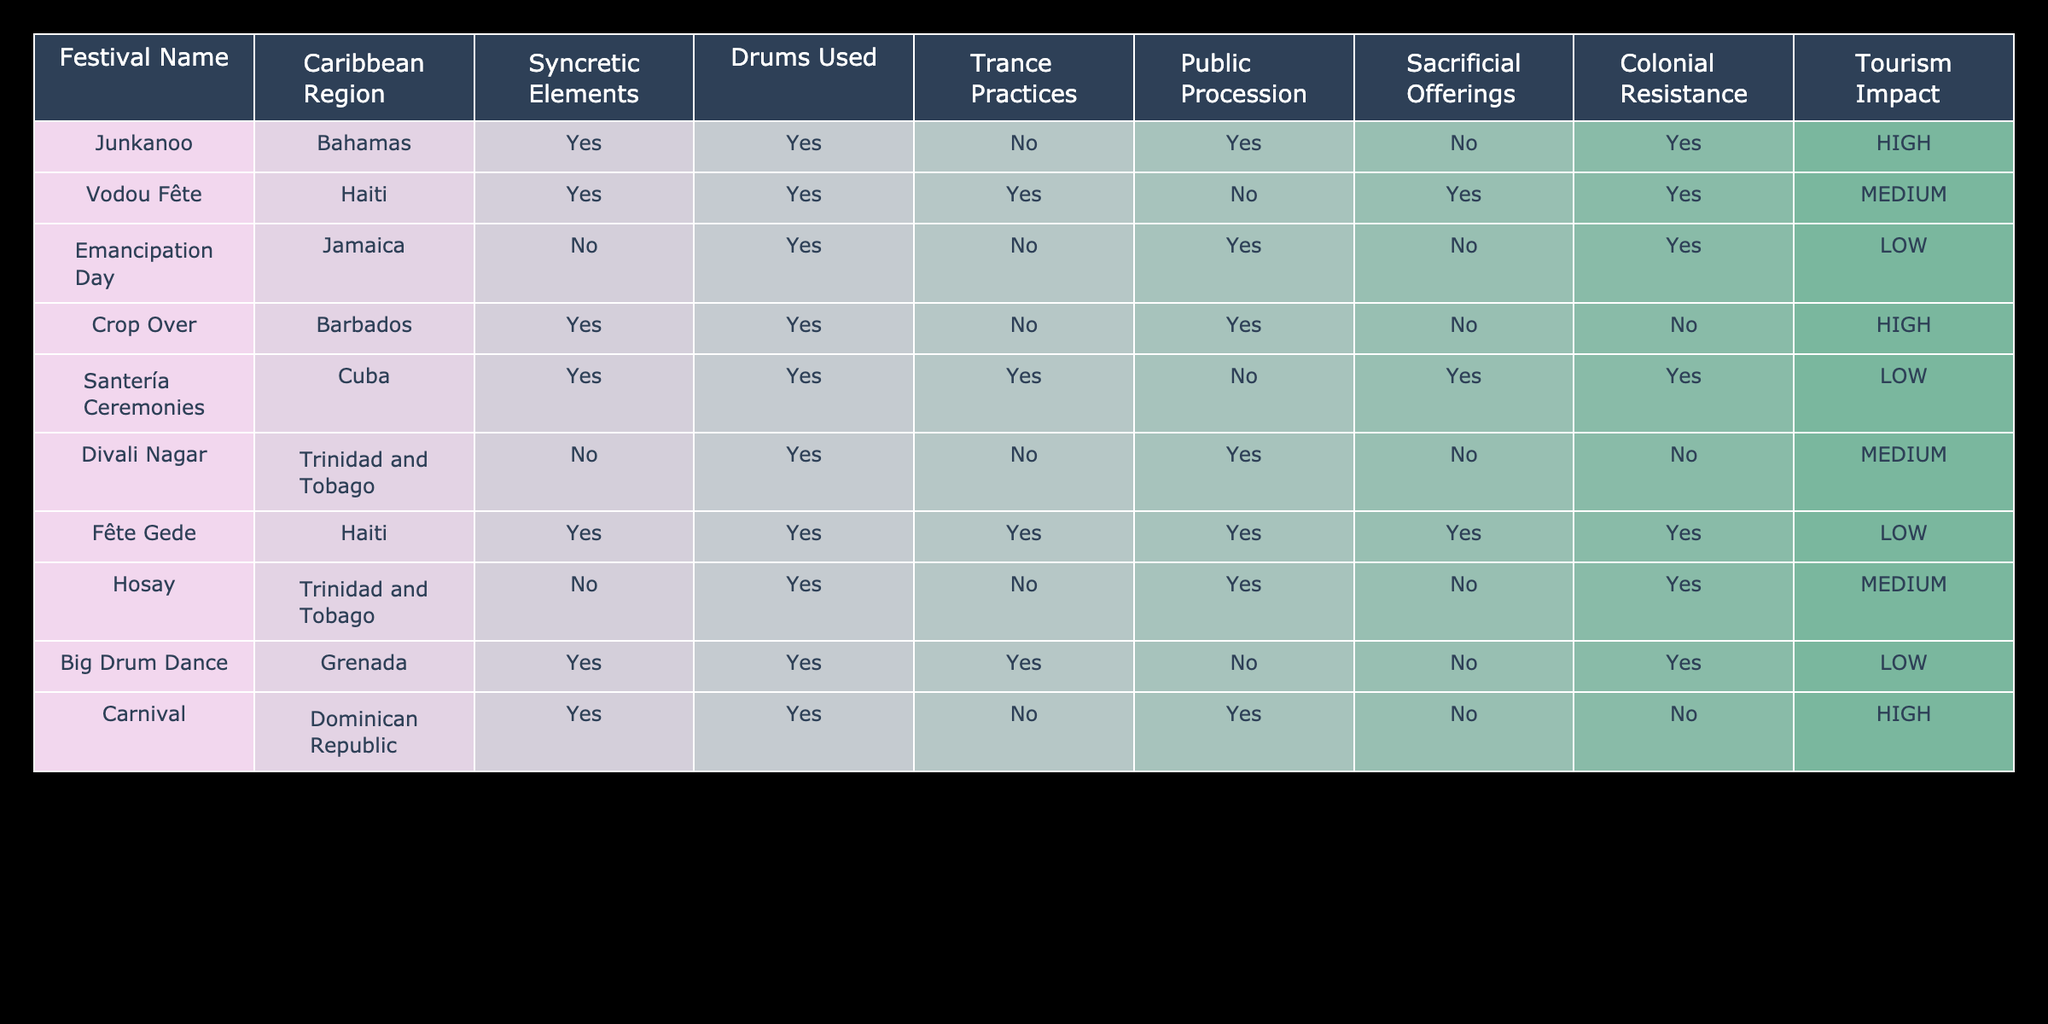What percentage of festivals include syncretic elements? There are 10 festivals in total, and 6 of them (Junkanoo, Vodou Fête, Crop Over, Santería Ceremonies, Fête Gede, Carnival) include syncretic elements. To calculate the percentage, divide 6 by 10 and multiply by 100, resulting in 60%.
Answer: 60% Which festival has the highest tourism impact? By examining the tourism impact column, we can see that both Junkanoo and Carnival are marked as high.
Answer: Junkanoo and Carnival Is there a festival that features sacrificial offerings and trance practices? Looking through the table, Fête Gede has both sacrificial offerings and trance practices marked as yes.
Answer: Yes How many festivals have public processions but do not have trance practices? By checking the table, we find that Emancipation Day, Divali Nagar, and Hosay have public processions and do not include trance practices. Thus, that's 3 festivals.
Answer: 3 What is the difference in the number of festivals with drums used versus those without drums used? From the table, all except for Emancipation Day, Divali Nagar, and Big Drum Dance use drums. Therefore, 7 festivals use drums, and 3 do not. The difference is 7 - 3 = 4.
Answer: 4 Which festival has the lowest tourism impact and features colonial resistance? Referring to the tourism impact column, we see that both Santería Ceremonies and Big Drum Dance have a low impact. However, only Santería Ceremonies appears with colonial resistance marked as yes.
Answer: Santería Ceremonies Are there any festivals that both have syncretic elements and are considered a form of colonial resistance? Looking at the table, Junkanoo, Vodou Fête, and Fête Gede have syncretic elements and colonial resistance marked as yes.
Answer: Yes How many festivals are celebrated in Trinidad and Tobago, and what is their average tourism impact? There are 2 festivals in Trinidad and Tobago (Divali Nagar and Hosay). Their tourism impacts are medium and medium, which can be assigned a value of 2 (medium). The average, therefore, is 2/2 = 2 (both considered medium).
Answer: 2 